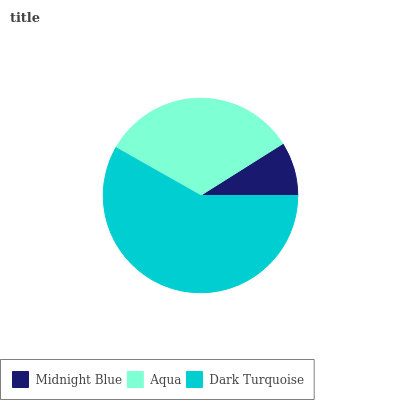Is Midnight Blue the minimum?
Answer yes or no. Yes. Is Dark Turquoise the maximum?
Answer yes or no. Yes. Is Aqua the minimum?
Answer yes or no. No. Is Aqua the maximum?
Answer yes or no. No. Is Aqua greater than Midnight Blue?
Answer yes or no. Yes. Is Midnight Blue less than Aqua?
Answer yes or no. Yes. Is Midnight Blue greater than Aqua?
Answer yes or no. No. Is Aqua less than Midnight Blue?
Answer yes or no. No. Is Aqua the high median?
Answer yes or no. Yes. Is Aqua the low median?
Answer yes or no. Yes. Is Dark Turquoise the high median?
Answer yes or no. No. Is Midnight Blue the low median?
Answer yes or no. No. 